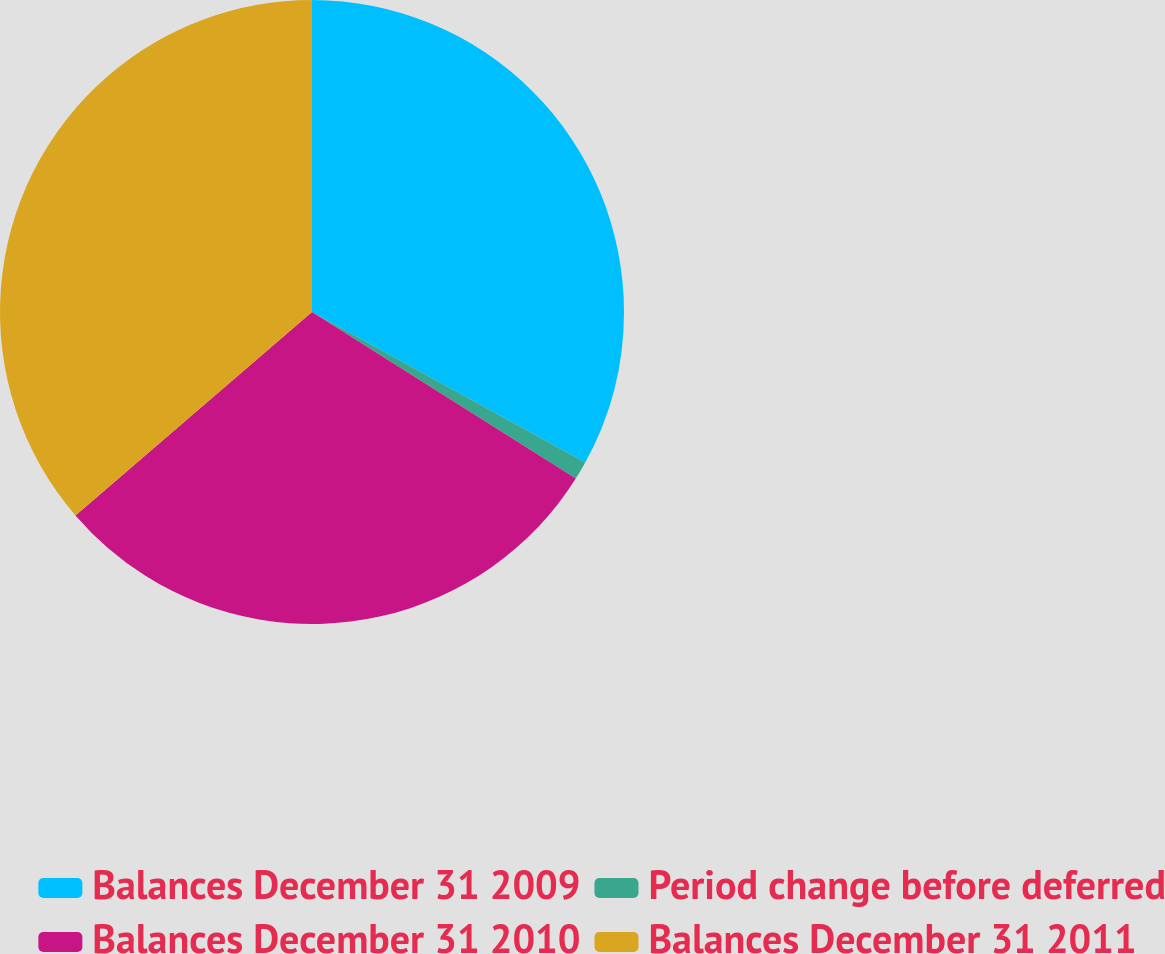Convert chart. <chart><loc_0><loc_0><loc_500><loc_500><pie_chart><fcel>Balances December 31 2009<fcel>Period change before deferred<fcel>Balances December 31 2010<fcel>Balances December 31 2011<nl><fcel>33.02%<fcel>0.95%<fcel>29.73%<fcel>36.31%<nl></chart> 